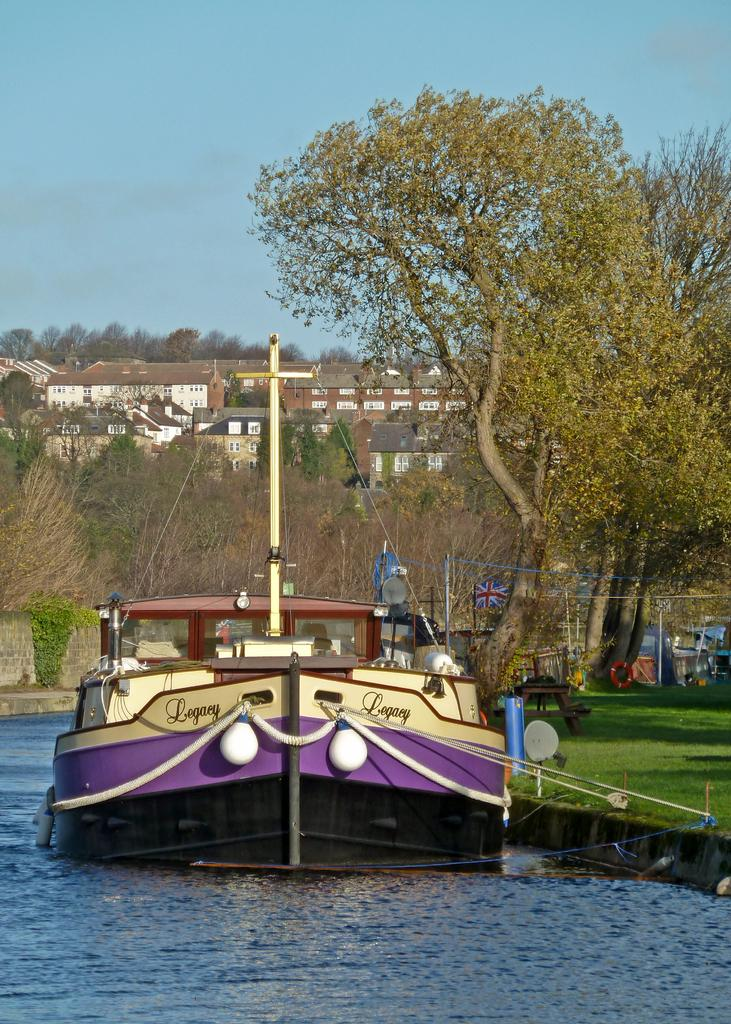What is the main subject of the image? The main subject of the image is a boat. What features can be seen on the boat? The boat has ropes. Where is the boat located? The boat is placed in the water. What can be seen in the background of the image? There is a flag on a pole, a group of trees, buildings, and the sky visible in the background. How many circles can be seen in the image? There are no circles present in the image. What type of van is parked near the boat in the image? There is no van present in the image; it features a boat in the water with a background that includes a flag, trees, buildings, and the sky. 